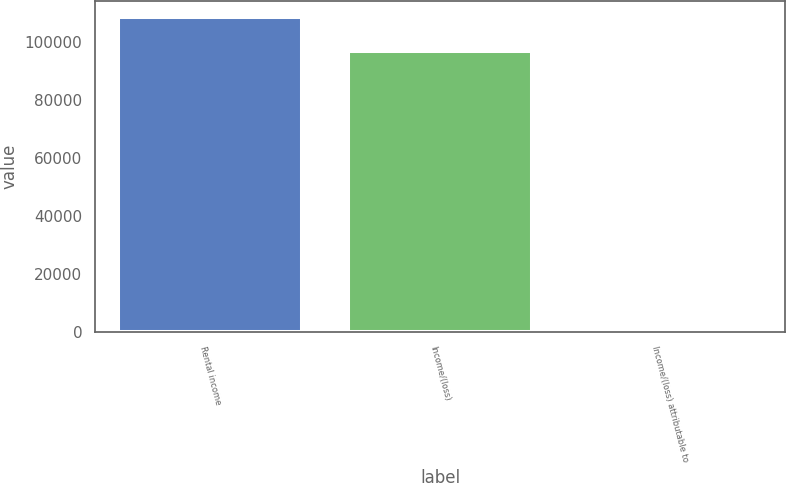<chart> <loc_0><loc_0><loc_500><loc_500><bar_chart><fcel>Rental income<fcel>Income/(loss)<fcel>Income/(loss) attributable to<nl><fcel>108523<fcel>96732.2<fcel>0.47<nl></chart> 